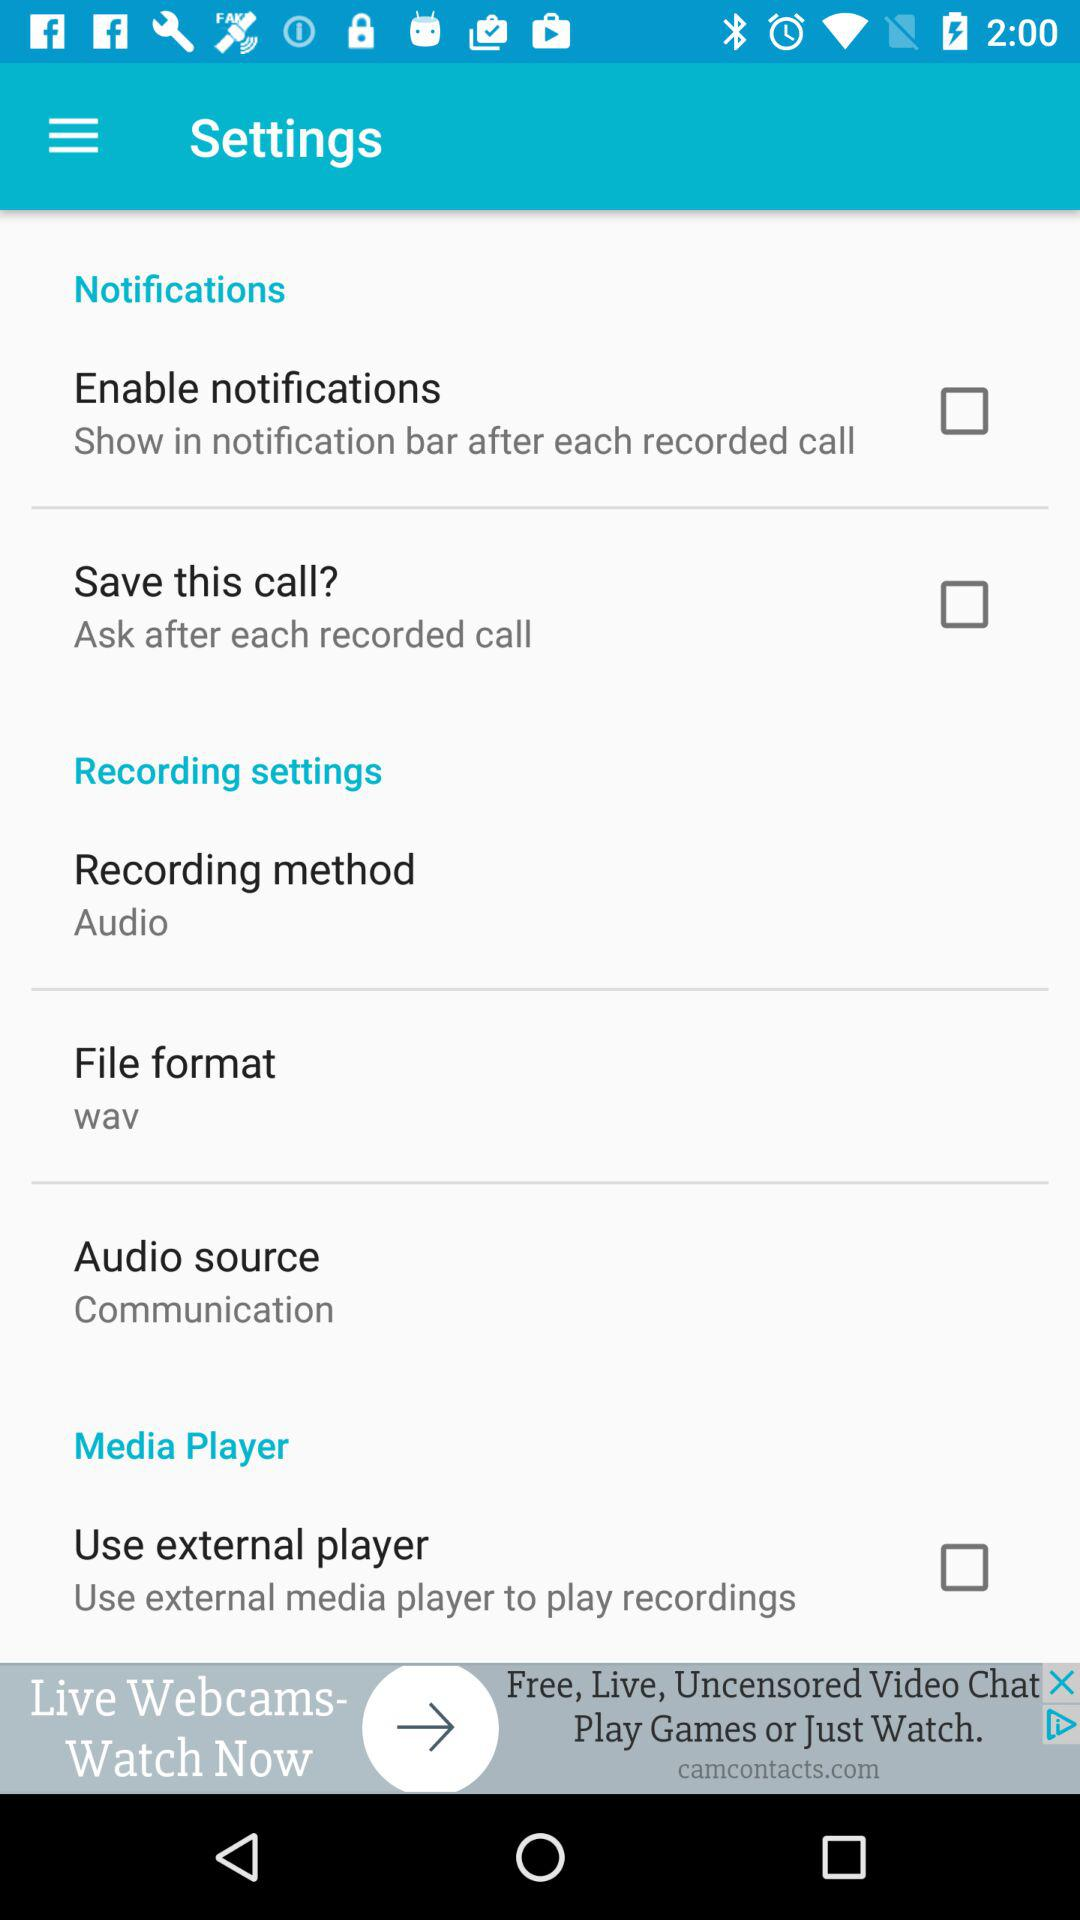What is the file format? The file format is WAV. 